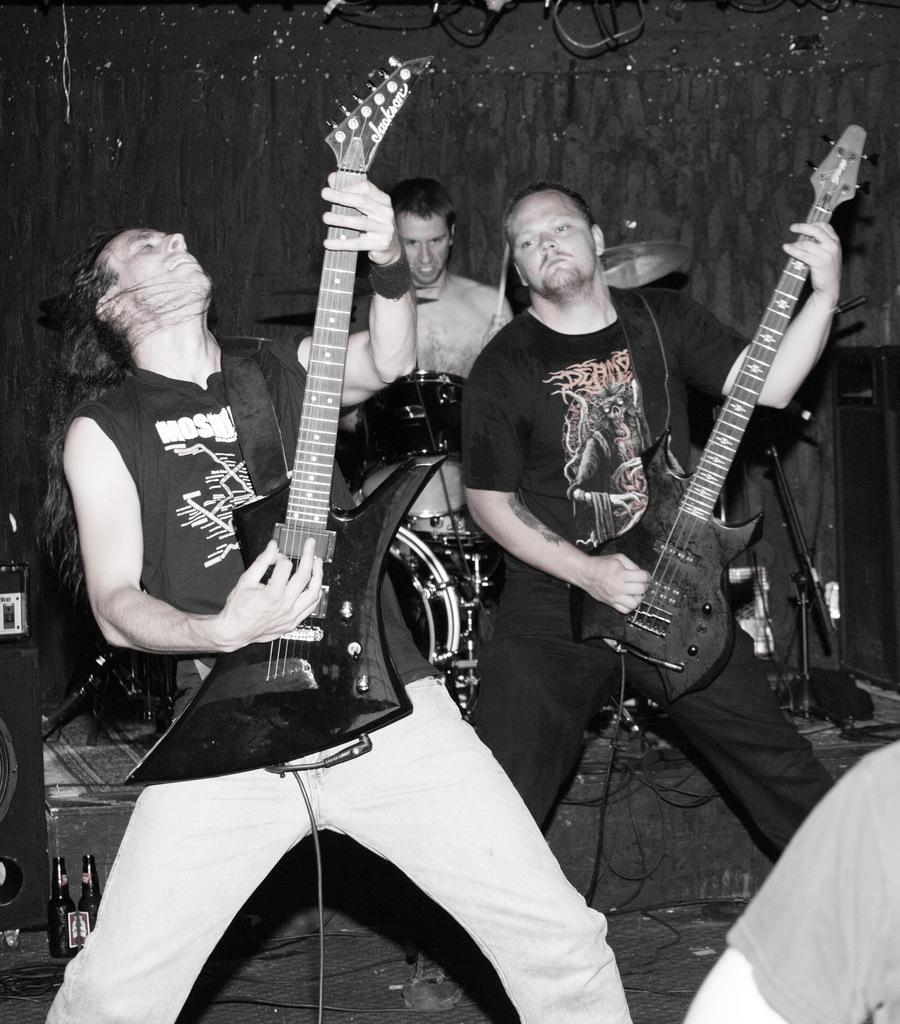How many people are in the image? There are three men in the image. What are the men doing in the image? The men are playing musical instruments. What can be seen in the background of the image? There is a wall in the background of the image. What type of company is being represented by the rabbits in the image? There are no rabbits present in the image, so it is not possible to determine what type of company they might represent. 